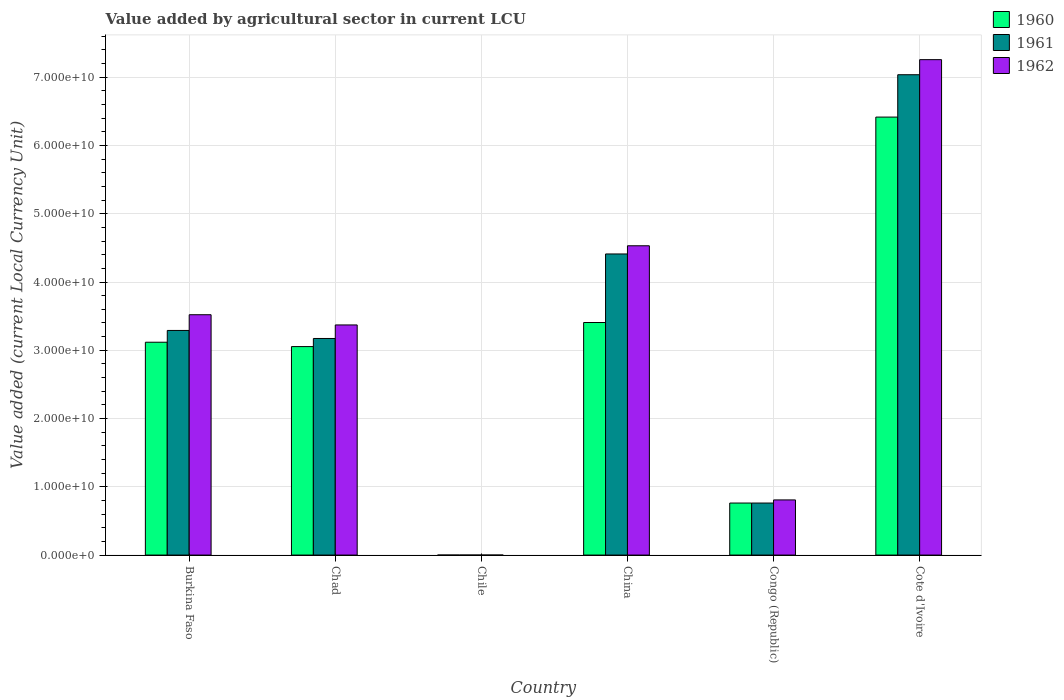Are the number of bars per tick equal to the number of legend labels?
Offer a terse response. Yes. How many bars are there on the 4th tick from the left?
Ensure brevity in your answer.  3. How many bars are there on the 3rd tick from the right?
Ensure brevity in your answer.  3. What is the label of the 4th group of bars from the left?
Your answer should be compact. China. In how many cases, is the number of bars for a given country not equal to the number of legend labels?
Provide a short and direct response. 0. What is the value added by agricultural sector in 1960 in China?
Ensure brevity in your answer.  3.41e+1. Across all countries, what is the maximum value added by agricultural sector in 1960?
Offer a very short reply. 6.42e+1. Across all countries, what is the minimum value added by agricultural sector in 1960?
Provide a short and direct response. 4.00e+05. In which country was the value added by agricultural sector in 1962 maximum?
Your answer should be compact. Cote d'Ivoire. What is the total value added by agricultural sector in 1962 in the graph?
Your answer should be compact. 1.95e+11. What is the difference between the value added by agricultural sector in 1960 in Burkina Faso and that in China?
Your answer should be very brief. -2.89e+09. What is the difference between the value added by agricultural sector in 1960 in Congo (Republic) and the value added by agricultural sector in 1962 in Cote d'Ivoire?
Offer a terse response. -6.50e+1. What is the average value added by agricultural sector in 1962 per country?
Keep it short and to the point. 3.25e+1. What is the ratio of the value added by agricultural sector in 1962 in Chad to that in China?
Provide a short and direct response. 0.74. What is the difference between the highest and the second highest value added by agricultural sector in 1960?
Provide a succinct answer. 3.30e+1. What is the difference between the highest and the lowest value added by agricultural sector in 1962?
Offer a very short reply. 7.26e+1. What does the 1st bar from the right in Burkina Faso represents?
Offer a very short reply. 1962. How many bars are there?
Provide a succinct answer. 18. Does the graph contain grids?
Your answer should be very brief. Yes. Where does the legend appear in the graph?
Offer a terse response. Top right. How many legend labels are there?
Make the answer very short. 3. What is the title of the graph?
Keep it short and to the point. Value added by agricultural sector in current LCU. Does "2003" appear as one of the legend labels in the graph?
Offer a terse response. No. What is the label or title of the X-axis?
Provide a short and direct response. Country. What is the label or title of the Y-axis?
Give a very brief answer. Value added (current Local Currency Unit). What is the Value added (current Local Currency Unit) in 1960 in Burkina Faso?
Offer a terse response. 3.12e+1. What is the Value added (current Local Currency Unit) in 1961 in Burkina Faso?
Give a very brief answer. 3.29e+1. What is the Value added (current Local Currency Unit) of 1962 in Burkina Faso?
Provide a short and direct response. 3.52e+1. What is the Value added (current Local Currency Unit) of 1960 in Chad?
Keep it short and to the point. 3.05e+1. What is the Value added (current Local Currency Unit) in 1961 in Chad?
Offer a very short reply. 3.17e+1. What is the Value added (current Local Currency Unit) in 1962 in Chad?
Offer a terse response. 3.37e+1. What is the Value added (current Local Currency Unit) in 1960 in China?
Make the answer very short. 3.41e+1. What is the Value added (current Local Currency Unit) in 1961 in China?
Your answer should be very brief. 4.41e+1. What is the Value added (current Local Currency Unit) of 1962 in China?
Your response must be concise. 4.53e+1. What is the Value added (current Local Currency Unit) in 1960 in Congo (Republic)?
Offer a very short reply. 7.62e+09. What is the Value added (current Local Currency Unit) in 1961 in Congo (Republic)?
Make the answer very short. 7.62e+09. What is the Value added (current Local Currency Unit) of 1962 in Congo (Republic)?
Provide a short and direct response. 8.08e+09. What is the Value added (current Local Currency Unit) in 1960 in Cote d'Ivoire?
Make the answer very short. 6.42e+1. What is the Value added (current Local Currency Unit) of 1961 in Cote d'Ivoire?
Your answer should be very brief. 7.04e+1. What is the Value added (current Local Currency Unit) in 1962 in Cote d'Ivoire?
Offer a very short reply. 7.26e+1. Across all countries, what is the maximum Value added (current Local Currency Unit) in 1960?
Your answer should be very brief. 6.42e+1. Across all countries, what is the maximum Value added (current Local Currency Unit) in 1961?
Provide a succinct answer. 7.04e+1. Across all countries, what is the maximum Value added (current Local Currency Unit) in 1962?
Your response must be concise. 7.26e+1. Across all countries, what is the minimum Value added (current Local Currency Unit) in 1960?
Make the answer very short. 4.00e+05. Across all countries, what is the minimum Value added (current Local Currency Unit) in 1961?
Offer a terse response. 5.00e+05. Across all countries, what is the minimum Value added (current Local Currency Unit) of 1962?
Ensure brevity in your answer.  5.00e+05. What is the total Value added (current Local Currency Unit) of 1960 in the graph?
Your answer should be very brief. 1.68e+11. What is the total Value added (current Local Currency Unit) in 1961 in the graph?
Offer a very short reply. 1.87e+11. What is the total Value added (current Local Currency Unit) of 1962 in the graph?
Give a very brief answer. 1.95e+11. What is the difference between the Value added (current Local Currency Unit) of 1960 in Burkina Faso and that in Chad?
Keep it short and to the point. 6.41e+08. What is the difference between the Value added (current Local Currency Unit) in 1961 in Burkina Faso and that in Chad?
Give a very brief answer. 1.18e+09. What is the difference between the Value added (current Local Currency Unit) in 1962 in Burkina Faso and that in Chad?
Ensure brevity in your answer.  1.50e+09. What is the difference between the Value added (current Local Currency Unit) in 1960 in Burkina Faso and that in Chile?
Give a very brief answer. 3.12e+1. What is the difference between the Value added (current Local Currency Unit) in 1961 in Burkina Faso and that in Chile?
Ensure brevity in your answer.  3.29e+1. What is the difference between the Value added (current Local Currency Unit) of 1962 in Burkina Faso and that in Chile?
Provide a short and direct response. 3.52e+1. What is the difference between the Value added (current Local Currency Unit) of 1960 in Burkina Faso and that in China?
Offer a terse response. -2.89e+09. What is the difference between the Value added (current Local Currency Unit) of 1961 in Burkina Faso and that in China?
Keep it short and to the point. -1.12e+1. What is the difference between the Value added (current Local Currency Unit) in 1962 in Burkina Faso and that in China?
Offer a very short reply. -1.01e+1. What is the difference between the Value added (current Local Currency Unit) of 1960 in Burkina Faso and that in Congo (Republic)?
Offer a terse response. 2.36e+1. What is the difference between the Value added (current Local Currency Unit) of 1961 in Burkina Faso and that in Congo (Republic)?
Ensure brevity in your answer.  2.53e+1. What is the difference between the Value added (current Local Currency Unit) in 1962 in Burkina Faso and that in Congo (Republic)?
Offer a very short reply. 2.71e+1. What is the difference between the Value added (current Local Currency Unit) in 1960 in Burkina Faso and that in Cote d'Ivoire?
Ensure brevity in your answer.  -3.30e+1. What is the difference between the Value added (current Local Currency Unit) of 1961 in Burkina Faso and that in Cote d'Ivoire?
Give a very brief answer. -3.75e+1. What is the difference between the Value added (current Local Currency Unit) of 1962 in Burkina Faso and that in Cote d'Ivoire?
Provide a succinct answer. -3.74e+1. What is the difference between the Value added (current Local Currency Unit) in 1960 in Chad and that in Chile?
Offer a terse response. 3.05e+1. What is the difference between the Value added (current Local Currency Unit) of 1961 in Chad and that in Chile?
Offer a terse response. 3.17e+1. What is the difference between the Value added (current Local Currency Unit) in 1962 in Chad and that in Chile?
Provide a short and direct response. 3.37e+1. What is the difference between the Value added (current Local Currency Unit) in 1960 in Chad and that in China?
Provide a succinct answer. -3.53e+09. What is the difference between the Value added (current Local Currency Unit) in 1961 in Chad and that in China?
Make the answer very short. -1.24e+1. What is the difference between the Value added (current Local Currency Unit) in 1962 in Chad and that in China?
Provide a short and direct response. -1.16e+1. What is the difference between the Value added (current Local Currency Unit) in 1960 in Chad and that in Congo (Republic)?
Keep it short and to the point. 2.29e+1. What is the difference between the Value added (current Local Currency Unit) of 1961 in Chad and that in Congo (Republic)?
Provide a succinct answer. 2.41e+1. What is the difference between the Value added (current Local Currency Unit) of 1962 in Chad and that in Congo (Republic)?
Your response must be concise. 2.56e+1. What is the difference between the Value added (current Local Currency Unit) in 1960 in Chad and that in Cote d'Ivoire?
Offer a very short reply. -3.36e+1. What is the difference between the Value added (current Local Currency Unit) in 1961 in Chad and that in Cote d'Ivoire?
Provide a short and direct response. -3.86e+1. What is the difference between the Value added (current Local Currency Unit) of 1962 in Chad and that in Cote d'Ivoire?
Your response must be concise. -3.89e+1. What is the difference between the Value added (current Local Currency Unit) of 1960 in Chile and that in China?
Ensure brevity in your answer.  -3.41e+1. What is the difference between the Value added (current Local Currency Unit) in 1961 in Chile and that in China?
Provide a short and direct response. -4.41e+1. What is the difference between the Value added (current Local Currency Unit) in 1962 in Chile and that in China?
Give a very brief answer. -4.53e+1. What is the difference between the Value added (current Local Currency Unit) in 1960 in Chile and that in Congo (Republic)?
Keep it short and to the point. -7.62e+09. What is the difference between the Value added (current Local Currency Unit) in 1961 in Chile and that in Congo (Republic)?
Provide a short and direct response. -7.62e+09. What is the difference between the Value added (current Local Currency Unit) of 1962 in Chile and that in Congo (Republic)?
Provide a succinct answer. -8.08e+09. What is the difference between the Value added (current Local Currency Unit) in 1960 in Chile and that in Cote d'Ivoire?
Offer a terse response. -6.42e+1. What is the difference between the Value added (current Local Currency Unit) in 1961 in Chile and that in Cote d'Ivoire?
Provide a succinct answer. -7.04e+1. What is the difference between the Value added (current Local Currency Unit) of 1962 in Chile and that in Cote d'Ivoire?
Make the answer very short. -7.26e+1. What is the difference between the Value added (current Local Currency Unit) of 1960 in China and that in Congo (Republic)?
Make the answer very short. 2.64e+1. What is the difference between the Value added (current Local Currency Unit) of 1961 in China and that in Congo (Republic)?
Give a very brief answer. 3.65e+1. What is the difference between the Value added (current Local Currency Unit) in 1962 in China and that in Congo (Republic)?
Give a very brief answer. 3.72e+1. What is the difference between the Value added (current Local Currency Unit) in 1960 in China and that in Cote d'Ivoire?
Provide a succinct answer. -3.01e+1. What is the difference between the Value added (current Local Currency Unit) in 1961 in China and that in Cote d'Ivoire?
Ensure brevity in your answer.  -2.63e+1. What is the difference between the Value added (current Local Currency Unit) in 1962 in China and that in Cote d'Ivoire?
Give a very brief answer. -2.73e+1. What is the difference between the Value added (current Local Currency Unit) in 1960 in Congo (Republic) and that in Cote d'Ivoire?
Offer a very short reply. -5.65e+1. What is the difference between the Value added (current Local Currency Unit) in 1961 in Congo (Republic) and that in Cote d'Ivoire?
Your answer should be very brief. -6.27e+1. What is the difference between the Value added (current Local Currency Unit) of 1962 in Congo (Republic) and that in Cote d'Ivoire?
Your answer should be compact. -6.45e+1. What is the difference between the Value added (current Local Currency Unit) of 1960 in Burkina Faso and the Value added (current Local Currency Unit) of 1961 in Chad?
Your answer should be very brief. -5.49e+08. What is the difference between the Value added (current Local Currency Unit) of 1960 in Burkina Faso and the Value added (current Local Currency Unit) of 1962 in Chad?
Give a very brief answer. -2.53e+09. What is the difference between the Value added (current Local Currency Unit) of 1961 in Burkina Faso and the Value added (current Local Currency Unit) of 1962 in Chad?
Your answer should be very brief. -8.07e+08. What is the difference between the Value added (current Local Currency Unit) of 1960 in Burkina Faso and the Value added (current Local Currency Unit) of 1961 in Chile?
Make the answer very short. 3.12e+1. What is the difference between the Value added (current Local Currency Unit) in 1960 in Burkina Faso and the Value added (current Local Currency Unit) in 1962 in Chile?
Your answer should be compact. 3.12e+1. What is the difference between the Value added (current Local Currency Unit) of 1961 in Burkina Faso and the Value added (current Local Currency Unit) of 1962 in Chile?
Keep it short and to the point. 3.29e+1. What is the difference between the Value added (current Local Currency Unit) in 1960 in Burkina Faso and the Value added (current Local Currency Unit) in 1961 in China?
Offer a terse response. -1.29e+1. What is the difference between the Value added (current Local Currency Unit) in 1960 in Burkina Faso and the Value added (current Local Currency Unit) in 1962 in China?
Your response must be concise. -1.41e+1. What is the difference between the Value added (current Local Currency Unit) of 1961 in Burkina Faso and the Value added (current Local Currency Unit) of 1962 in China?
Offer a terse response. -1.24e+1. What is the difference between the Value added (current Local Currency Unit) in 1960 in Burkina Faso and the Value added (current Local Currency Unit) in 1961 in Congo (Republic)?
Provide a short and direct response. 2.36e+1. What is the difference between the Value added (current Local Currency Unit) in 1960 in Burkina Faso and the Value added (current Local Currency Unit) in 1962 in Congo (Republic)?
Give a very brief answer. 2.31e+1. What is the difference between the Value added (current Local Currency Unit) of 1961 in Burkina Faso and the Value added (current Local Currency Unit) of 1962 in Congo (Republic)?
Ensure brevity in your answer.  2.48e+1. What is the difference between the Value added (current Local Currency Unit) in 1960 in Burkina Faso and the Value added (current Local Currency Unit) in 1961 in Cote d'Ivoire?
Provide a succinct answer. -3.92e+1. What is the difference between the Value added (current Local Currency Unit) of 1960 in Burkina Faso and the Value added (current Local Currency Unit) of 1962 in Cote d'Ivoire?
Your response must be concise. -4.14e+1. What is the difference between the Value added (current Local Currency Unit) in 1961 in Burkina Faso and the Value added (current Local Currency Unit) in 1962 in Cote d'Ivoire?
Ensure brevity in your answer.  -3.97e+1. What is the difference between the Value added (current Local Currency Unit) of 1960 in Chad and the Value added (current Local Currency Unit) of 1961 in Chile?
Provide a short and direct response. 3.05e+1. What is the difference between the Value added (current Local Currency Unit) in 1960 in Chad and the Value added (current Local Currency Unit) in 1962 in Chile?
Give a very brief answer. 3.05e+1. What is the difference between the Value added (current Local Currency Unit) of 1961 in Chad and the Value added (current Local Currency Unit) of 1962 in Chile?
Offer a terse response. 3.17e+1. What is the difference between the Value added (current Local Currency Unit) of 1960 in Chad and the Value added (current Local Currency Unit) of 1961 in China?
Give a very brief answer. -1.36e+1. What is the difference between the Value added (current Local Currency Unit) in 1960 in Chad and the Value added (current Local Currency Unit) in 1962 in China?
Give a very brief answer. -1.48e+1. What is the difference between the Value added (current Local Currency Unit) of 1961 in Chad and the Value added (current Local Currency Unit) of 1962 in China?
Your answer should be compact. -1.36e+1. What is the difference between the Value added (current Local Currency Unit) of 1960 in Chad and the Value added (current Local Currency Unit) of 1961 in Congo (Republic)?
Your response must be concise. 2.29e+1. What is the difference between the Value added (current Local Currency Unit) of 1960 in Chad and the Value added (current Local Currency Unit) of 1962 in Congo (Republic)?
Ensure brevity in your answer.  2.25e+1. What is the difference between the Value added (current Local Currency Unit) of 1961 in Chad and the Value added (current Local Currency Unit) of 1962 in Congo (Republic)?
Give a very brief answer. 2.37e+1. What is the difference between the Value added (current Local Currency Unit) of 1960 in Chad and the Value added (current Local Currency Unit) of 1961 in Cote d'Ivoire?
Provide a succinct answer. -3.98e+1. What is the difference between the Value added (current Local Currency Unit) of 1960 in Chad and the Value added (current Local Currency Unit) of 1962 in Cote d'Ivoire?
Provide a succinct answer. -4.20e+1. What is the difference between the Value added (current Local Currency Unit) of 1961 in Chad and the Value added (current Local Currency Unit) of 1962 in Cote d'Ivoire?
Provide a succinct answer. -4.08e+1. What is the difference between the Value added (current Local Currency Unit) of 1960 in Chile and the Value added (current Local Currency Unit) of 1961 in China?
Your answer should be compact. -4.41e+1. What is the difference between the Value added (current Local Currency Unit) of 1960 in Chile and the Value added (current Local Currency Unit) of 1962 in China?
Provide a short and direct response. -4.53e+1. What is the difference between the Value added (current Local Currency Unit) in 1961 in Chile and the Value added (current Local Currency Unit) in 1962 in China?
Offer a terse response. -4.53e+1. What is the difference between the Value added (current Local Currency Unit) in 1960 in Chile and the Value added (current Local Currency Unit) in 1961 in Congo (Republic)?
Make the answer very short. -7.62e+09. What is the difference between the Value added (current Local Currency Unit) of 1960 in Chile and the Value added (current Local Currency Unit) of 1962 in Congo (Republic)?
Your answer should be compact. -8.08e+09. What is the difference between the Value added (current Local Currency Unit) of 1961 in Chile and the Value added (current Local Currency Unit) of 1962 in Congo (Republic)?
Give a very brief answer. -8.08e+09. What is the difference between the Value added (current Local Currency Unit) of 1960 in Chile and the Value added (current Local Currency Unit) of 1961 in Cote d'Ivoire?
Offer a very short reply. -7.04e+1. What is the difference between the Value added (current Local Currency Unit) in 1960 in Chile and the Value added (current Local Currency Unit) in 1962 in Cote d'Ivoire?
Ensure brevity in your answer.  -7.26e+1. What is the difference between the Value added (current Local Currency Unit) in 1961 in Chile and the Value added (current Local Currency Unit) in 1962 in Cote d'Ivoire?
Provide a short and direct response. -7.26e+1. What is the difference between the Value added (current Local Currency Unit) in 1960 in China and the Value added (current Local Currency Unit) in 1961 in Congo (Republic)?
Your answer should be compact. 2.64e+1. What is the difference between the Value added (current Local Currency Unit) in 1960 in China and the Value added (current Local Currency Unit) in 1962 in Congo (Republic)?
Ensure brevity in your answer.  2.60e+1. What is the difference between the Value added (current Local Currency Unit) of 1961 in China and the Value added (current Local Currency Unit) of 1962 in Congo (Republic)?
Your response must be concise. 3.60e+1. What is the difference between the Value added (current Local Currency Unit) of 1960 in China and the Value added (current Local Currency Unit) of 1961 in Cote d'Ivoire?
Offer a terse response. -3.63e+1. What is the difference between the Value added (current Local Currency Unit) in 1960 in China and the Value added (current Local Currency Unit) in 1962 in Cote d'Ivoire?
Your response must be concise. -3.85e+1. What is the difference between the Value added (current Local Currency Unit) in 1961 in China and the Value added (current Local Currency Unit) in 1962 in Cote d'Ivoire?
Ensure brevity in your answer.  -2.85e+1. What is the difference between the Value added (current Local Currency Unit) of 1960 in Congo (Republic) and the Value added (current Local Currency Unit) of 1961 in Cote d'Ivoire?
Provide a short and direct response. -6.27e+1. What is the difference between the Value added (current Local Currency Unit) of 1960 in Congo (Republic) and the Value added (current Local Currency Unit) of 1962 in Cote d'Ivoire?
Offer a very short reply. -6.50e+1. What is the difference between the Value added (current Local Currency Unit) of 1961 in Congo (Republic) and the Value added (current Local Currency Unit) of 1962 in Cote d'Ivoire?
Your response must be concise. -6.50e+1. What is the average Value added (current Local Currency Unit) in 1960 per country?
Make the answer very short. 2.79e+1. What is the average Value added (current Local Currency Unit) in 1961 per country?
Offer a very short reply. 3.11e+1. What is the average Value added (current Local Currency Unit) in 1962 per country?
Offer a terse response. 3.25e+1. What is the difference between the Value added (current Local Currency Unit) of 1960 and Value added (current Local Currency Unit) of 1961 in Burkina Faso?
Give a very brief answer. -1.73e+09. What is the difference between the Value added (current Local Currency Unit) in 1960 and Value added (current Local Currency Unit) in 1962 in Burkina Faso?
Your answer should be very brief. -4.03e+09. What is the difference between the Value added (current Local Currency Unit) in 1961 and Value added (current Local Currency Unit) in 1962 in Burkina Faso?
Offer a terse response. -2.30e+09. What is the difference between the Value added (current Local Currency Unit) of 1960 and Value added (current Local Currency Unit) of 1961 in Chad?
Your response must be concise. -1.19e+09. What is the difference between the Value added (current Local Currency Unit) in 1960 and Value added (current Local Currency Unit) in 1962 in Chad?
Offer a terse response. -3.17e+09. What is the difference between the Value added (current Local Currency Unit) in 1961 and Value added (current Local Currency Unit) in 1962 in Chad?
Your answer should be very brief. -1.98e+09. What is the difference between the Value added (current Local Currency Unit) of 1960 and Value added (current Local Currency Unit) of 1961 in Chile?
Ensure brevity in your answer.  -1.00e+05. What is the difference between the Value added (current Local Currency Unit) of 1960 and Value added (current Local Currency Unit) of 1962 in Chile?
Provide a succinct answer. -1.00e+05. What is the difference between the Value added (current Local Currency Unit) of 1960 and Value added (current Local Currency Unit) of 1961 in China?
Your answer should be compact. -1.00e+1. What is the difference between the Value added (current Local Currency Unit) of 1960 and Value added (current Local Currency Unit) of 1962 in China?
Provide a succinct answer. -1.12e+1. What is the difference between the Value added (current Local Currency Unit) in 1961 and Value added (current Local Currency Unit) in 1962 in China?
Provide a succinct answer. -1.20e+09. What is the difference between the Value added (current Local Currency Unit) of 1960 and Value added (current Local Currency Unit) of 1962 in Congo (Republic)?
Keep it short and to the point. -4.57e+08. What is the difference between the Value added (current Local Currency Unit) in 1961 and Value added (current Local Currency Unit) in 1962 in Congo (Republic)?
Your answer should be compact. -4.57e+08. What is the difference between the Value added (current Local Currency Unit) of 1960 and Value added (current Local Currency Unit) of 1961 in Cote d'Ivoire?
Give a very brief answer. -6.21e+09. What is the difference between the Value added (current Local Currency Unit) of 1960 and Value added (current Local Currency Unit) of 1962 in Cote d'Ivoire?
Your answer should be compact. -8.41e+09. What is the difference between the Value added (current Local Currency Unit) of 1961 and Value added (current Local Currency Unit) of 1962 in Cote d'Ivoire?
Provide a short and direct response. -2.21e+09. What is the ratio of the Value added (current Local Currency Unit) of 1960 in Burkina Faso to that in Chad?
Your answer should be compact. 1.02. What is the ratio of the Value added (current Local Currency Unit) in 1961 in Burkina Faso to that in Chad?
Give a very brief answer. 1.04. What is the ratio of the Value added (current Local Currency Unit) of 1962 in Burkina Faso to that in Chad?
Make the answer very short. 1.04. What is the ratio of the Value added (current Local Currency Unit) in 1960 in Burkina Faso to that in Chile?
Ensure brevity in your answer.  7.80e+04. What is the ratio of the Value added (current Local Currency Unit) in 1961 in Burkina Faso to that in Chile?
Ensure brevity in your answer.  6.58e+04. What is the ratio of the Value added (current Local Currency Unit) in 1962 in Burkina Faso to that in Chile?
Give a very brief answer. 7.04e+04. What is the ratio of the Value added (current Local Currency Unit) of 1960 in Burkina Faso to that in China?
Offer a terse response. 0.92. What is the ratio of the Value added (current Local Currency Unit) of 1961 in Burkina Faso to that in China?
Provide a succinct answer. 0.75. What is the ratio of the Value added (current Local Currency Unit) of 1962 in Burkina Faso to that in China?
Give a very brief answer. 0.78. What is the ratio of the Value added (current Local Currency Unit) in 1960 in Burkina Faso to that in Congo (Republic)?
Give a very brief answer. 4.09. What is the ratio of the Value added (current Local Currency Unit) of 1961 in Burkina Faso to that in Congo (Republic)?
Provide a succinct answer. 4.32. What is the ratio of the Value added (current Local Currency Unit) of 1962 in Burkina Faso to that in Congo (Republic)?
Keep it short and to the point. 4.36. What is the ratio of the Value added (current Local Currency Unit) of 1960 in Burkina Faso to that in Cote d'Ivoire?
Your answer should be very brief. 0.49. What is the ratio of the Value added (current Local Currency Unit) of 1961 in Burkina Faso to that in Cote d'Ivoire?
Provide a succinct answer. 0.47. What is the ratio of the Value added (current Local Currency Unit) of 1962 in Burkina Faso to that in Cote d'Ivoire?
Offer a terse response. 0.49. What is the ratio of the Value added (current Local Currency Unit) of 1960 in Chad to that in Chile?
Your answer should be very brief. 7.64e+04. What is the ratio of the Value added (current Local Currency Unit) in 1961 in Chad to that in Chile?
Your answer should be compact. 6.35e+04. What is the ratio of the Value added (current Local Currency Unit) in 1962 in Chad to that in Chile?
Your answer should be very brief. 6.74e+04. What is the ratio of the Value added (current Local Currency Unit) in 1960 in Chad to that in China?
Provide a short and direct response. 0.9. What is the ratio of the Value added (current Local Currency Unit) of 1961 in Chad to that in China?
Ensure brevity in your answer.  0.72. What is the ratio of the Value added (current Local Currency Unit) in 1962 in Chad to that in China?
Offer a very short reply. 0.74. What is the ratio of the Value added (current Local Currency Unit) in 1960 in Chad to that in Congo (Republic)?
Provide a short and direct response. 4.01. What is the ratio of the Value added (current Local Currency Unit) of 1961 in Chad to that in Congo (Republic)?
Ensure brevity in your answer.  4.16. What is the ratio of the Value added (current Local Currency Unit) in 1962 in Chad to that in Congo (Republic)?
Give a very brief answer. 4.17. What is the ratio of the Value added (current Local Currency Unit) in 1960 in Chad to that in Cote d'Ivoire?
Keep it short and to the point. 0.48. What is the ratio of the Value added (current Local Currency Unit) in 1961 in Chad to that in Cote d'Ivoire?
Offer a terse response. 0.45. What is the ratio of the Value added (current Local Currency Unit) of 1962 in Chad to that in Cote d'Ivoire?
Keep it short and to the point. 0.46. What is the ratio of the Value added (current Local Currency Unit) in 1960 in Chile to that in China?
Ensure brevity in your answer.  0. What is the ratio of the Value added (current Local Currency Unit) in 1961 in Chile to that in China?
Give a very brief answer. 0. What is the ratio of the Value added (current Local Currency Unit) in 1962 in Chile to that in China?
Offer a terse response. 0. What is the ratio of the Value added (current Local Currency Unit) of 1960 in Chile to that in Congo (Republic)?
Offer a very short reply. 0. What is the ratio of the Value added (current Local Currency Unit) in 1961 in Chile to that in Congo (Republic)?
Offer a very short reply. 0. What is the ratio of the Value added (current Local Currency Unit) in 1962 in Chile to that in Congo (Republic)?
Your response must be concise. 0. What is the ratio of the Value added (current Local Currency Unit) of 1960 in Chile to that in Cote d'Ivoire?
Keep it short and to the point. 0. What is the ratio of the Value added (current Local Currency Unit) in 1960 in China to that in Congo (Republic)?
Provide a short and direct response. 4.47. What is the ratio of the Value added (current Local Currency Unit) in 1961 in China to that in Congo (Republic)?
Keep it short and to the point. 5.79. What is the ratio of the Value added (current Local Currency Unit) in 1962 in China to that in Congo (Republic)?
Give a very brief answer. 5.61. What is the ratio of the Value added (current Local Currency Unit) in 1960 in China to that in Cote d'Ivoire?
Keep it short and to the point. 0.53. What is the ratio of the Value added (current Local Currency Unit) in 1961 in China to that in Cote d'Ivoire?
Keep it short and to the point. 0.63. What is the ratio of the Value added (current Local Currency Unit) in 1962 in China to that in Cote d'Ivoire?
Your answer should be compact. 0.62. What is the ratio of the Value added (current Local Currency Unit) in 1960 in Congo (Republic) to that in Cote d'Ivoire?
Ensure brevity in your answer.  0.12. What is the ratio of the Value added (current Local Currency Unit) of 1961 in Congo (Republic) to that in Cote d'Ivoire?
Offer a terse response. 0.11. What is the ratio of the Value added (current Local Currency Unit) of 1962 in Congo (Republic) to that in Cote d'Ivoire?
Offer a very short reply. 0.11. What is the difference between the highest and the second highest Value added (current Local Currency Unit) in 1960?
Your response must be concise. 3.01e+1. What is the difference between the highest and the second highest Value added (current Local Currency Unit) of 1961?
Your answer should be compact. 2.63e+1. What is the difference between the highest and the second highest Value added (current Local Currency Unit) of 1962?
Your answer should be very brief. 2.73e+1. What is the difference between the highest and the lowest Value added (current Local Currency Unit) in 1960?
Offer a terse response. 6.42e+1. What is the difference between the highest and the lowest Value added (current Local Currency Unit) in 1961?
Your answer should be compact. 7.04e+1. What is the difference between the highest and the lowest Value added (current Local Currency Unit) in 1962?
Ensure brevity in your answer.  7.26e+1. 